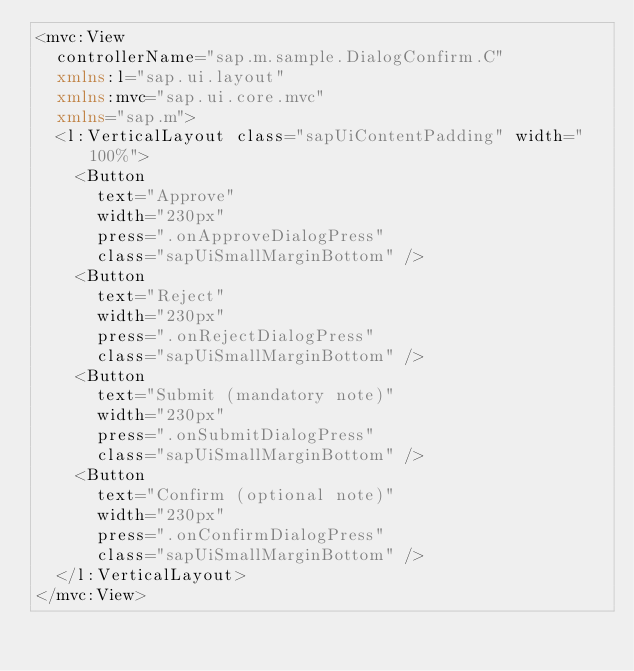Convert code to text. <code><loc_0><loc_0><loc_500><loc_500><_XML_><mvc:View
	controllerName="sap.m.sample.DialogConfirm.C"
	xmlns:l="sap.ui.layout"
	xmlns:mvc="sap.ui.core.mvc"
	xmlns="sap.m">
	<l:VerticalLayout class="sapUiContentPadding" width="100%">
		<Button
			text="Approve"
			width="230px"
			press=".onApproveDialogPress"
			class="sapUiSmallMarginBottom" />
		<Button
			text="Reject"
			width="230px"
			press=".onRejectDialogPress"
			class="sapUiSmallMarginBottom" />
		<Button
			text="Submit (mandatory note)"
			width="230px"
			press=".onSubmitDialogPress"
			class="sapUiSmallMarginBottom" />
		<Button
			text="Confirm (optional note)"
			width="230px"
			press=".onConfirmDialogPress"
			class="sapUiSmallMarginBottom" />
	</l:VerticalLayout>
</mvc:View></code> 